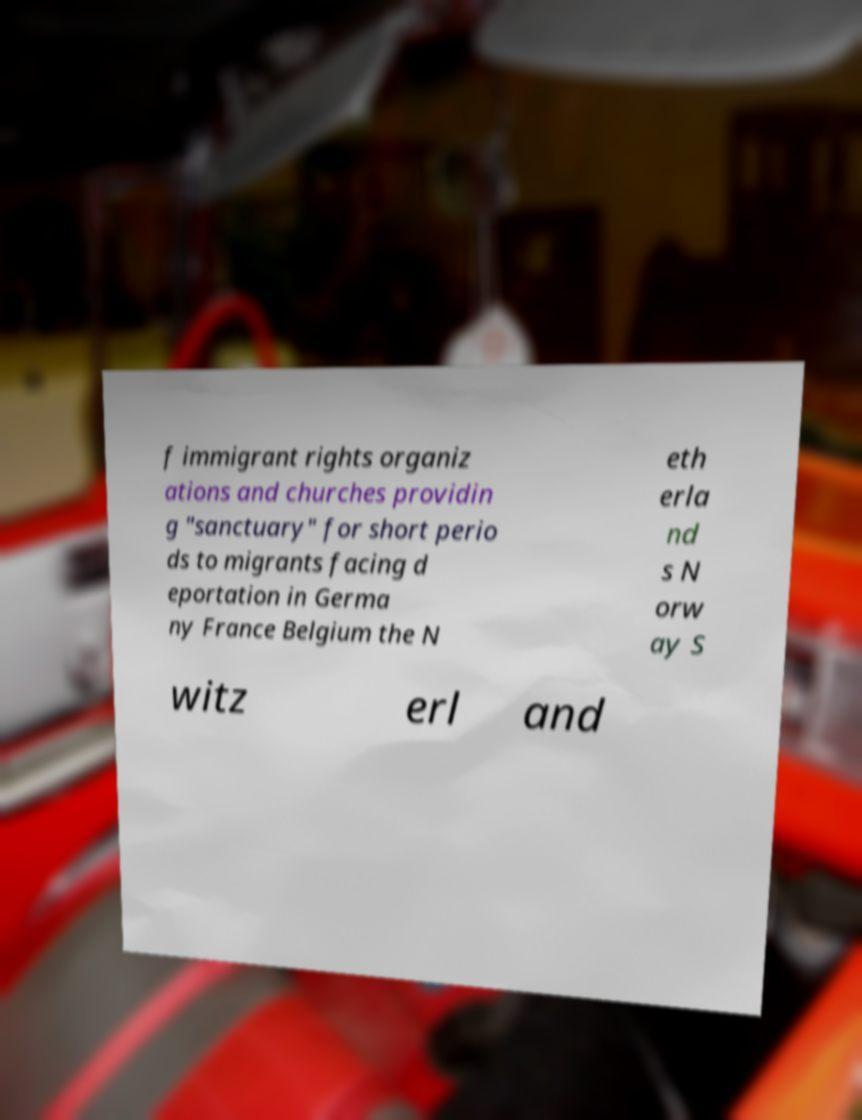For documentation purposes, I need the text within this image transcribed. Could you provide that? f immigrant rights organiz ations and churches providin g "sanctuary" for short perio ds to migrants facing d eportation in Germa ny France Belgium the N eth erla nd s N orw ay S witz erl and 